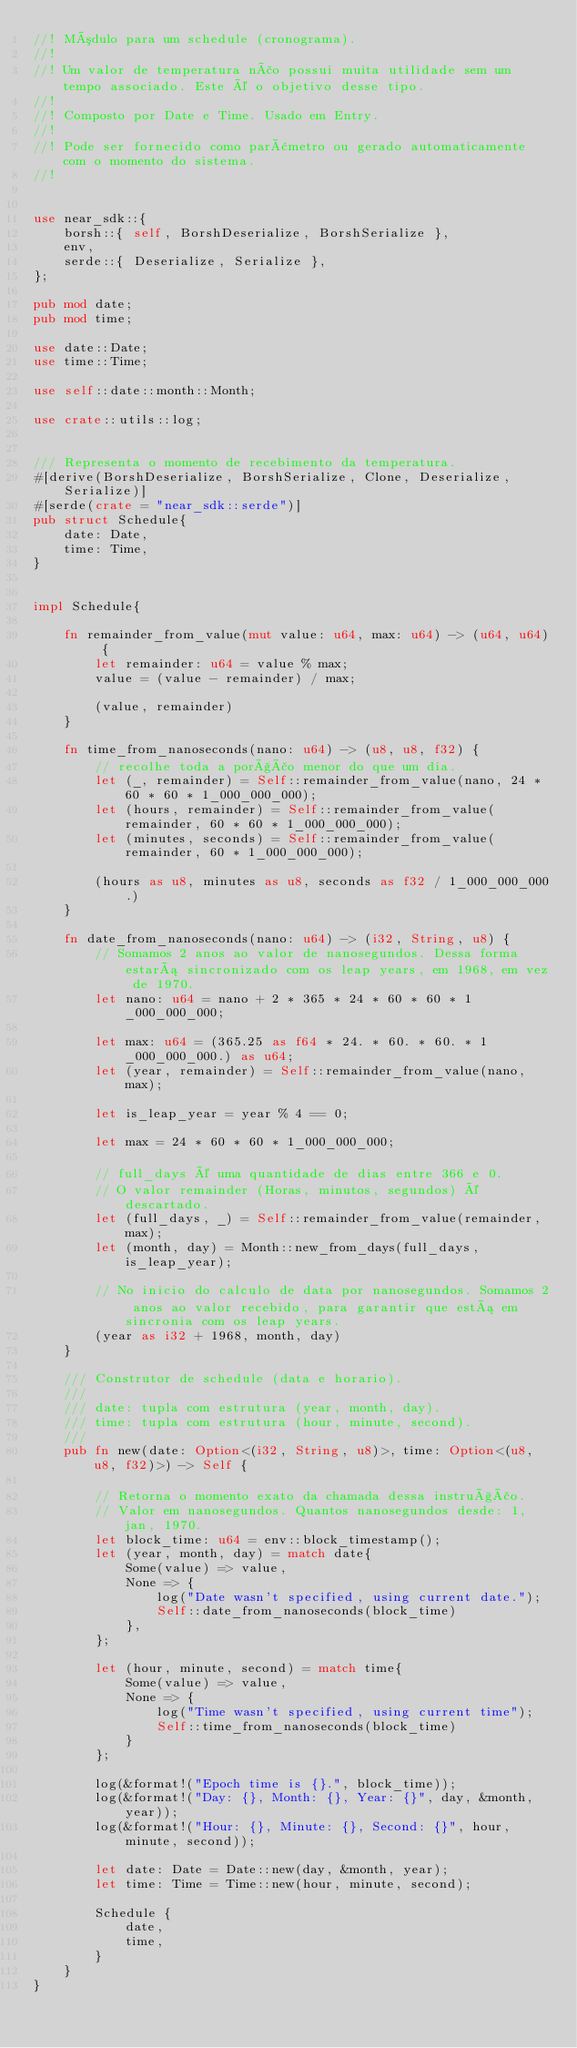<code> <loc_0><loc_0><loc_500><loc_500><_Rust_>//! Módulo para um schedule (cronograma).
//! 
//! Um valor de temperatura não possui muita utilidade sem um tempo associado. Este é o objetivo desse tipo.
//! 
//! Composto por Date e Time. Usado em Entry.
//! 
//! Pode ser fornecido como parâmetro ou gerado automaticamente com o momento do sistema.
//! 


use near_sdk::{
    borsh::{ self, BorshDeserialize, BorshSerialize },
    env,
    serde::{ Deserialize, Serialize },
};

pub mod date;
pub mod time;

use date::Date;
use time::Time;

use self::date::month::Month;

use crate::utils::log;


/// Representa o momento de recebimento da temperatura.
#[derive(BorshDeserialize, BorshSerialize, Clone, Deserialize, Serialize)]
#[serde(crate = "near_sdk::serde")]
pub struct Schedule{
    date: Date,
    time: Time,
}


impl Schedule{
    
    fn remainder_from_value(mut value: u64, max: u64) -> (u64, u64) {
        let remainder: u64 = value % max;
        value = (value - remainder) / max;

        (value, remainder)
    }

    fn time_from_nanoseconds(nano: u64) -> (u8, u8, f32) {
        // recolhe toda a porção menor do que um dia.
        let (_, remainder) = Self::remainder_from_value(nano, 24 * 60 * 60 * 1_000_000_000);
        let (hours, remainder) = Self::remainder_from_value(remainder, 60 * 60 * 1_000_000_000);
        let (minutes, seconds) = Self::remainder_from_value(remainder, 60 * 1_000_000_000);

        (hours as u8, minutes as u8, seconds as f32 / 1_000_000_000.)
    }

    fn date_from_nanoseconds(nano: u64) -> (i32, String, u8) {
        // Somamos 2 anos ao valor de nanosegundos. Dessa forma estará sincronizado com os leap years, em 1968, em vez de 1970.
        let nano: u64 = nano + 2 * 365 * 24 * 60 * 60 * 1_000_000_000;

        let max: u64 = (365.25 as f64 * 24. * 60. * 60. * 1_000_000_000.) as u64;
        let (year, remainder) = Self::remainder_from_value(nano, max);

        let is_leap_year = year % 4 == 0;

        let max = 24 * 60 * 60 * 1_000_000_000;

        // full_days é uma quantidade de dias entre 366 e 0.
        // O valor remainder (Horas, minutos, segundos) é descartado.
        let (full_days, _) = Self::remainder_from_value(remainder, max);
        let (month, day) = Month::new_from_days(full_days, is_leap_year);
        
        // No inicio do calculo de data por nanosegundos. Somamos 2 anos ao valor recebido, para garantir que está em sincronia com os leap years.
        (year as i32 + 1968, month, day)
    }

    /// Construtor de schedule (data e horario).
    /// 
    /// date: tupla com estrutura (year, month, day).
    /// time: tupla com estrutura (hour, minute, second).
    /// 
    pub fn new(date: Option<(i32, String, u8)>, time: Option<(u8, u8, f32)>) -> Self {
        
        // Retorna o momento exato da chamada dessa instrução.
        // Valor em nanosegundos. Quantos nanosegundos desde: 1, jan, 1970.
        let block_time: u64 = env::block_timestamp();
        let (year, month, day) = match date{
            Some(value) => value,
            None => {
                log("Date wasn't specified, using current date.");
                Self::date_from_nanoseconds(block_time)
            },
        };
        
        let (hour, minute, second) = match time{
            Some(value) => value,
            None => {
                log("Time wasn't specified, using current time");
                Self::time_from_nanoseconds(block_time)
            }
        };

        log(&format!("Epoch time is {}.", block_time));
        log(&format!("Day: {}, Month: {}, Year: {}", day, &month, year));
        log(&format!("Hour: {}, Minute: {}, Second: {}", hour, minute, second));

        let date: Date = Date::new(day, &month, year);
        let time: Time = Time::new(hour, minute, second);

        Schedule { 
            date,
            time,
        }
    }
}
</code> 